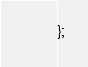Convert code to text. <code><loc_0><loc_0><loc_500><loc_500><_JavaScript_>};
</code> 